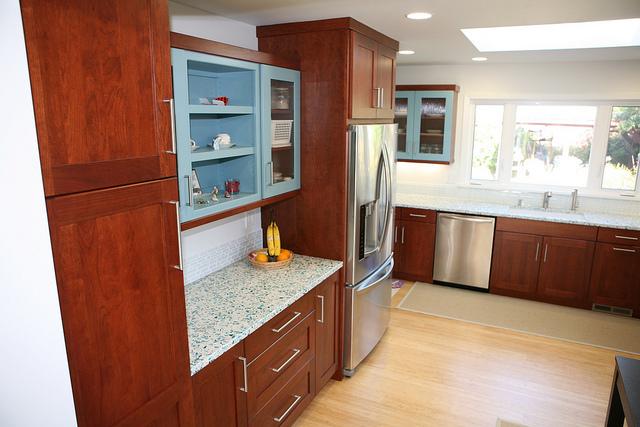Does this room have a lot of natural light?
Give a very brief answer. Yes. Where are the fruits?
Be succinct. On table. What area of the house is this?
Short answer required. Kitchen. What type of room is shown?
Give a very brief answer. Kitchen. 